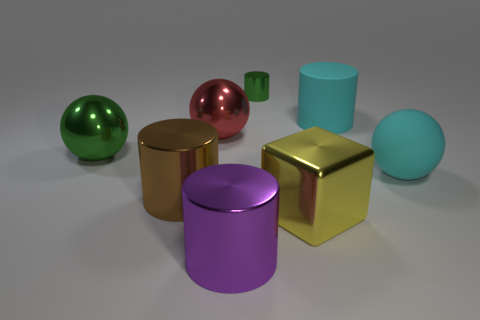There is a green thing on the left side of the small cylinder to the right of the cylinder that is in front of the brown shiny cylinder; what is its size?
Give a very brief answer. Large. What number of other things are the same material as the cyan cylinder?
Your answer should be compact. 1. What color is the large sphere that is right of the big red ball?
Give a very brief answer. Cyan. There is a cylinder behind the matte object that is behind the big object that is on the right side of the big cyan cylinder; what is it made of?
Offer a terse response. Metal. Are there any other yellow metallic objects of the same shape as the yellow metallic object?
Provide a succinct answer. No. There is a brown object that is the same size as the matte ball; what is its shape?
Give a very brief answer. Cylinder. How many large cylinders are on the left side of the yellow metal thing and behind the purple metallic thing?
Offer a terse response. 1. Is the number of green metallic balls in front of the cyan rubber sphere less than the number of big yellow metal blocks?
Offer a very short reply. Yes. Is there another matte thing of the same size as the yellow object?
Provide a succinct answer. Yes. There is a tiny cylinder that is the same material as the big red thing; what color is it?
Make the answer very short. Green. 